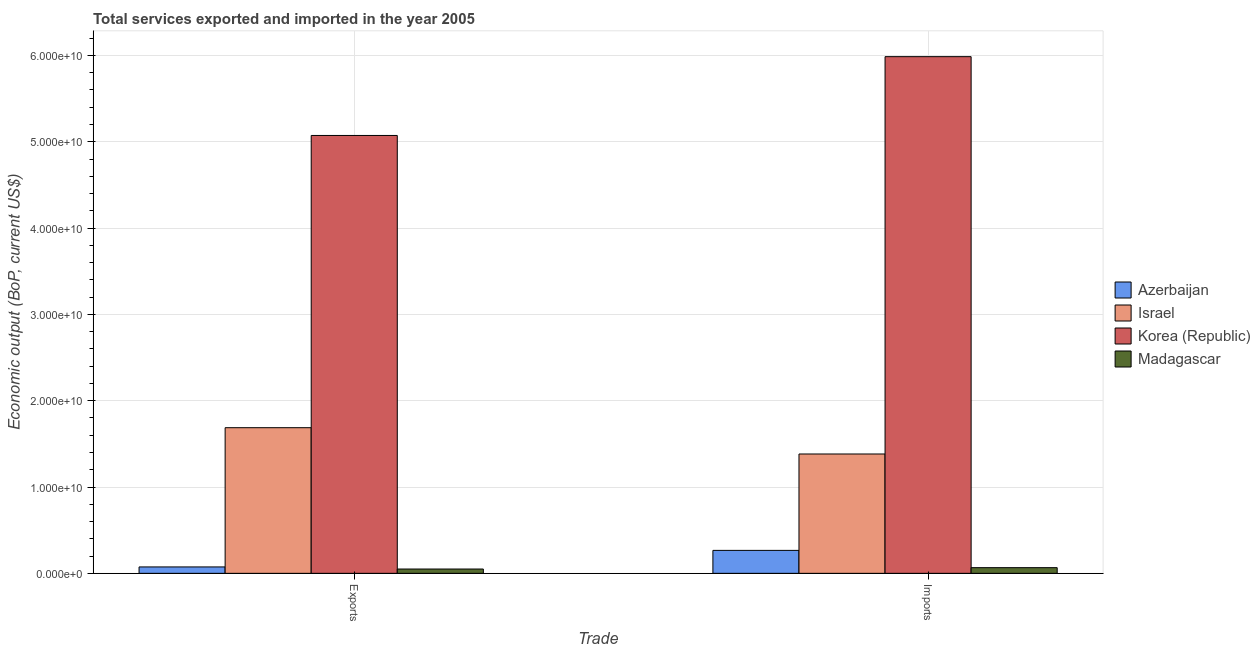How many different coloured bars are there?
Make the answer very short. 4. Are the number of bars on each tick of the X-axis equal?
Offer a terse response. Yes. How many bars are there on the 1st tick from the right?
Offer a terse response. 4. What is the label of the 1st group of bars from the left?
Your answer should be compact. Exports. What is the amount of service imports in Korea (Republic)?
Offer a very short reply. 5.99e+1. Across all countries, what is the maximum amount of service exports?
Ensure brevity in your answer.  5.07e+1. Across all countries, what is the minimum amount of service exports?
Make the answer very short. 4.99e+08. In which country was the amount of service imports maximum?
Give a very brief answer. Korea (Republic). In which country was the amount of service exports minimum?
Your answer should be compact. Madagascar. What is the total amount of service exports in the graph?
Keep it short and to the point. 6.88e+1. What is the difference between the amount of service imports in Korea (Republic) and that in Azerbaijan?
Keep it short and to the point. 5.72e+1. What is the difference between the amount of service exports in Israel and the amount of service imports in Madagascar?
Your answer should be very brief. 1.62e+1. What is the average amount of service imports per country?
Your response must be concise. 1.93e+1. What is the difference between the amount of service imports and amount of service exports in Madagascar?
Offer a terse response. 1.58e+08. In how many countries, is the amount of service exports greater than 50000000000 US$?
Offer a very short reply. 1. What is the ratio of the amount of service imports in Azerbaijan to that in Israel?
Offer a very short reply. 0.19. In how many countries, is the amount of service exports greater than the average amount of service exports taken over all countries?
Offer a very short reply. 1. What does the 4th bar from the left in Exports represents?
Your answer should be compact. Madagascar. How many countries are there in the graph?
Ensure brevity in your answer.  4. Does the graph contain grids?
Make the answer very short. Yes. Where does the legend appear in the graph?
Give a very brief answer. Center right. How many legend labels are there?
Keep it short and to the point. 4. How are the legend labels stacked?
Provide a short and direct response. Vertical. What is the title of the graph?
Give a very brief answer. Total services exported and imported in the year 2005. What is the label or title of the X-axis?
Your response must be concise. Trade. What is the label or title of the Y-axis?
Provide a succinct answer. Economic output (BoP, current US$). What is the Economic output (BoP, current US$) in Azerbaijan in Exports?
Keep it short and to the point. 7.41e+08. What is the Economic output (BoP, current US$) of Israel in Exports?
Your answer should be compact. 1.69e+1. What is the Economic output (BoP, current US$) of Korea (Republic) in Exports?
Ensure brevity in your answer.  5.07e+1. What is the Economic output (BoP, current US$) in Madagascar in Exports?
Offer a terse response. 4.99e+08. What is the Economic output (BoP, current US$) in Azerbaijan in Imports?
Your response must be concise. 2.66e+09. What is the Economic output (BoP, current US$) in Israel in Imports?
Offer a very short reply. 1.38e+1. What is the Economic output (BoP, current US$) of Korea (Republic) in Imports?
Provide a succinct answer. 5.99e+1. What is the Economic output (BoP, current US$) of Madagascar in Imports?
Offer a terse response. 6.57e+08. Across all Trade, what is the maximum Economic output (BoP, current US$) of Azerbaijan?
Offer a very short reply. 2.66e+09. Across all Trade, what is the maximum Economic output (BoP, current US$) of Israel?
Offer a very short reply. 1.69e+1. Across all Trade, what is the maximum Economic output (BoP, current US$) in Korea (Republic)?
Make the answer very short. 5.99e+1. Across all Trade, what is the maximum Economic output (BoP, current US$) in Madagascar?
Provide a short and direct response. 6.57e+08. Across all Trade, what is the minimum Economic output (BoP, current US$) of Azerbaijan?
Give a very brief answer. 7.41e+08. Across all Trade, what is the minimum Economic output (BoP, current US$) of Israel?
Offer a very short reply. 1.38e+1. Across all Trade, what is the minimum Economic output (BoP, current US$) in Korea (Republic)?
Give a very brief answer. 5.07e+1. Across all Trade, what is the minimum Economic output (BoP, current US$) of Madagascar?
Your answer should be compact. 4.99e+08. What is the total Economic output (BoP, current US$) of Azerbaijan in the graph?
Make the answer very short. 3.40e+09. What is the total Economic output (BoP, current US$) of Israel in the graph?
Offer a very short reply. 3.07e+1. What is the total Economic output (BoP, current US$) in Korea (Republic) in the graph?
Your answer should be compact. 1.11e+11. What is the total Economic output (BoP, current US$) of Madagascar in the graph?
Keep it short and to the point. 1.16e+09. What is the difference between the Economic output (BoP, current US$) in Azerbaijan in Exports and that in Imports?
Provide a short and direct response. -1.92e+09. What is the difference between the Economic output (BoP, current US$) in Israel in Exports and that in Imports?
Ensure brevity in your answer.  3.05e+09. What is the difference between the Economic output (BoP, current US$) of Korea (Republic) in Exports and that in Imports?
Give a very brief answer. -9.13e+09. What is the difference between the Economic output (BoP, current US$) of Madagascar in Exports and that in Imports?
Your response must be concise. -1.58e+08. What is the difference between the Economic output (BoP, current US$) in Azerbaijan in Exports and the Economic output (BoP, current US$) in Israel in Imports?
Your response must be concise. -1.31e+1. What is the difference between the Economic output (BoP, current US$) of Azerbaijan in Exports and the Economic output (BoP, current US$) of Korea (Republic) in Imports?
Ensure brevity in your answer.  -5.91e+1. What is the difference between the Economic output (BoP, current US$) of Azerbaijan in Exports and the Economic output (BoP, current US$) of Madagascar in Imports?
Provide a short and direct response. 8.46e+07. What is the difference between the Economic output (BoP, current US$) in Israel in Exports and the Economic output (BoP, current US$) in Korea (Republic) in Imports?
Your answer should be very brief. -4.30e+1. What is the difference between the Economic output (BoP, current US$) of Israel in Exports and the Economic output (BoP, current US$) of Madagascar in Imports?
Provide a succinct answer. 1.62e+1. What is the difference between the Economic output (BoP, current US$) of Korea (Republic) in Exports and the Economic output (BoP, current US$) of Madagascar in Imports?
Provide a succinct answer. 5.01e+1. What is the average Economic output (BoP, current US$) in Azerbaijan per Trade?
Ensure brevity in your answer.  1.70e+09. What is the average Economic output (BoP, current US$) in Israel per Trade?
Offer a very short reply. 1.53e+1. What is the average Economic output (BoP, current US$) in Korea (Republic) per Trade?
Your answer should be compact. 5.53e+1. What is the average Economic output (BoP, current US$) in Madagascar per Trade?
Offer a terse response. 5.78e+08. What is the difference between the Economic output (BoP, current US$) in Azerbaijan and Economic output (BoP, current US$) in Israel in Exports?
Offer a terse response. -1.61e+1. What is the difference between the Economic output (BoP, current US$) in Azerbaijan and Economic output (BoP, current US$) in Korea (Republic) in Exports?
Ensure brevity in your answer.  -5.00e+1. What is the difference between the Economic output (BoP, current US$) of Azerbaijan and Economic output (BoP, current US$) of Madagascar in Exports?
Your response must be concise. 2.42e+08. What is the difference between the Economic output (BoP, current US$) in Israel and Economic output (BoP, current US$) in Korea (Republic) in Exports?
Provide a succinct answer. -3.39e+1. What is the difference between the Economic output (BoP, current US$) of Israel and Economic output (BoP, current US$) of Madagascar in Exports?
Ensure brevity in your answer.  1.64e+1. What is the difference between the Economic output (BoP, current US$) of Korea (Republic) and Economic output (BoP, current US$) of Madagascar in Exports?
Keep it short and to the point. 5.02e+1. What is the difference between the Economic output (BoP, current US$) of Azerbaijan and Economic output (BoP, current US$) of Israel in Imports?
Provide a short and direct response. -1.12e+1. What is the difference between the Economic output (BoP, current US$) in Azerbaijan and Economic output (BoP, current US$) in Korea (Republic) in Imports?
Your answer should be compact. -5.72e+1. What is the difference between the Economic output (BoP, current US$) of Azerbaijan and Economic output (BoP, current US$) of Madagascar in Imports?
Keep it short and to the point. 2.00e+09. What is the difference between the Economic output (BoP, current US$) in Israel and Economic output (BoP, current US$) in Korea (Republic) in Imports?
Your response must be concise. -4.60e+1. What is the difference between the Economic output (BoP, current US$) of Israel and Economic output (BoP, current US$) of Madagascar in Imports?
Provide a succinct answer. 1.32e+1. What is the difference between the Economic output (BoP, current US$) in Korea (Republic) and Economic output (BoP, current US$) in Madagascar in Imports?
Your answer should be very brief. 5.92e+1. What is the ratio of the Economic output (BoP, current US$) in Azerbaijan in Exports to that in Imports?
Ensure brevity in your answer.  0.28. What is the ratio of the Economic output (BoP, current US$) of Israel in Exports to that in Imports?
Offer a terse response. 1.22. What is the ratio of the Economic output (BoP, current US$) in Korea (Republic) in Exports to that in Imports?
Your answer should be compact. 0.85. What is the ratio of the Economic output (BoP, current US$) of Madagascar in Exports to that in Imports?
Provide a short and direct response. 0.76. What is the difference between the highest and the second highest Economic output (BoP, current US$) of Azerbaijan?
Your response must be concise. 1.92e+09. What is the difference between the highest and the second highest Economic output (BoP, current US$) of Israel?
Offer a very short reply. 3.05e+09. What is the difference between the highest and the second highest Economic output (BoP, current US$) in Korea (Republic)?
Your answer should be very brief. 9.13e+09. What is the difference between the highest and the second highest Economic output (BoP, current US$) of Madagascar?
Provide a succinct answer. 1.58e+08. What is the difference between the highest and the lowest Economic output (BoP, current US$) of Azerbaijan?
Give a very brief answer. 1.92e+09. What is the difference between the highest and the lowest Economic output (BoP, current US$) in Israel?
Your answer should be very brief. 3.05e+09. What is the difference between the highest and the lowest Economic output (BoP, current US$) of Korea (Republic)?
Provide a succinct answer. 9.13e+09. What is the difference between the highest and the lowest Economic output (BoP, current US$) in Madagascar?
Your answer should be very brief. 1.58e+08. 